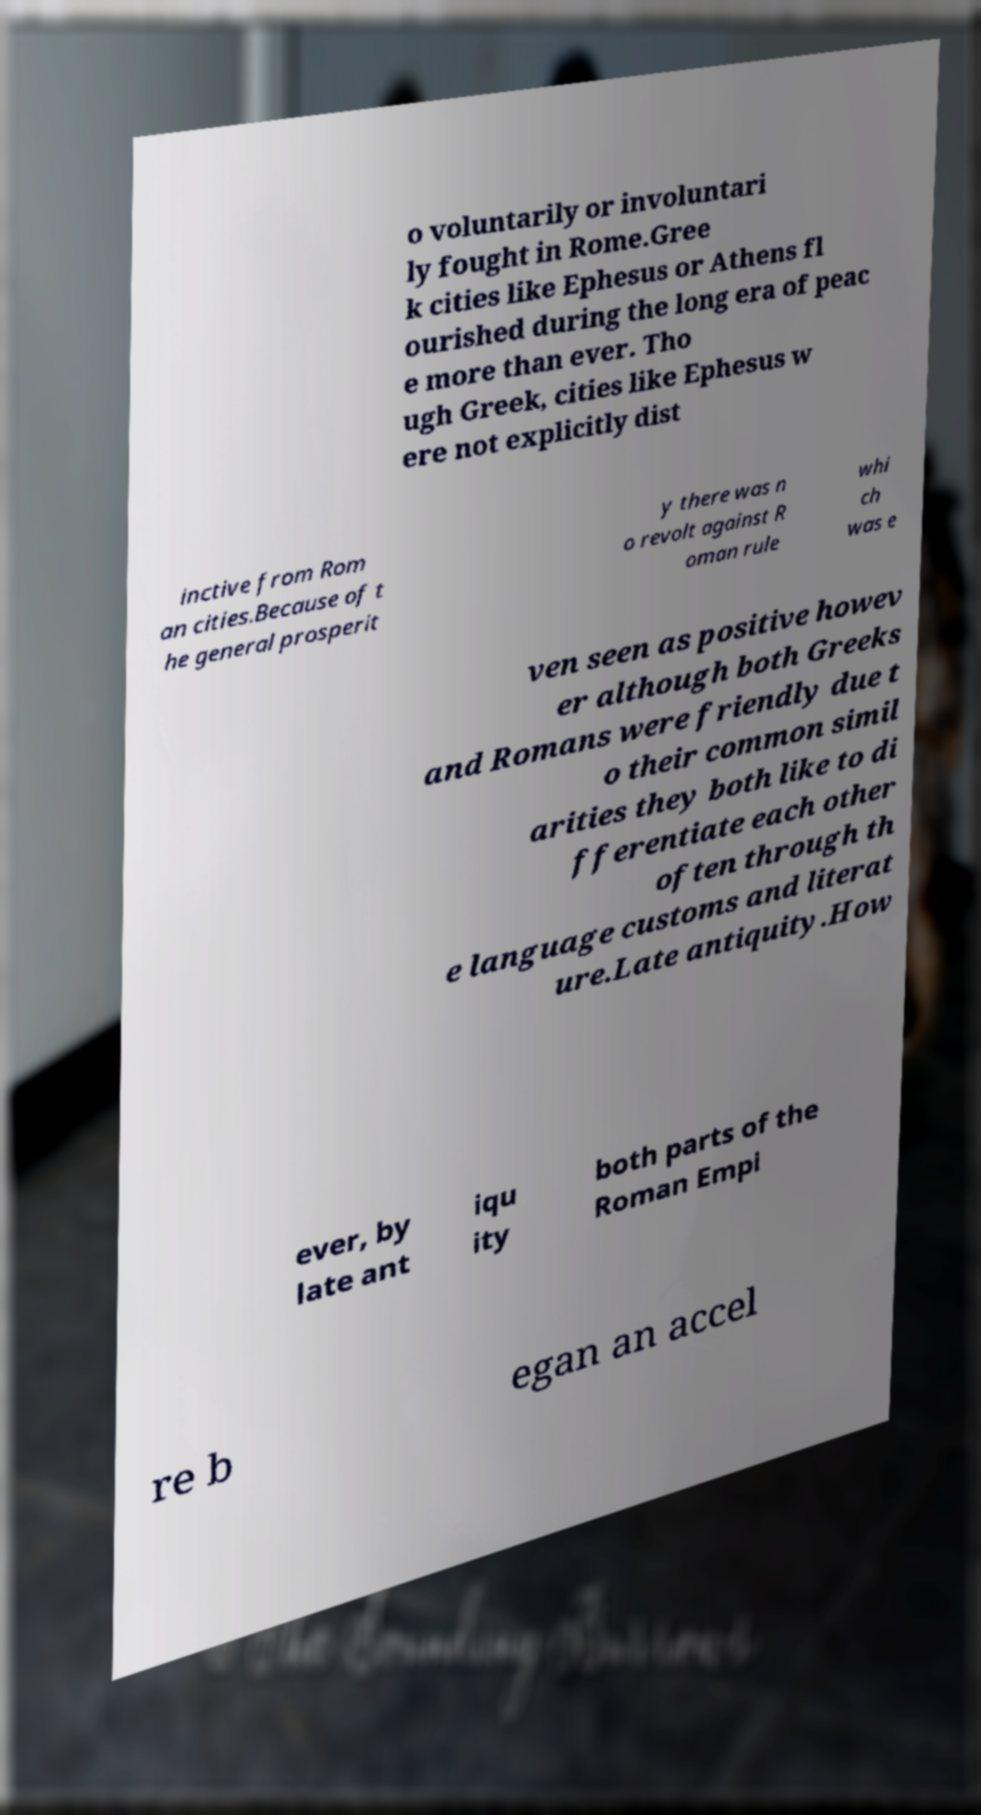Could you assist in decoding the text presented in this image and type it out clearly? o voluntarily or involuntari ly fought in Rome.Gree k cities like Ephesus or Athens fl ourished during the long era of peac e more than ever. Tho ugh Greek, cities like Ephesus w ere not explicitly dist inctive from Rom an cities.Because of t he general prosperit y there was n o revolt against R oman rule whi ch was e ven seen as positive howev er although both Greeks and Romans were friendly due t o their common simil arities they both like to di fferentiate each other often through th e language customs and literat ure.Late antiquity.How ever, by late ant iqu ity both parts of the Roman Empi re b egan an accel 